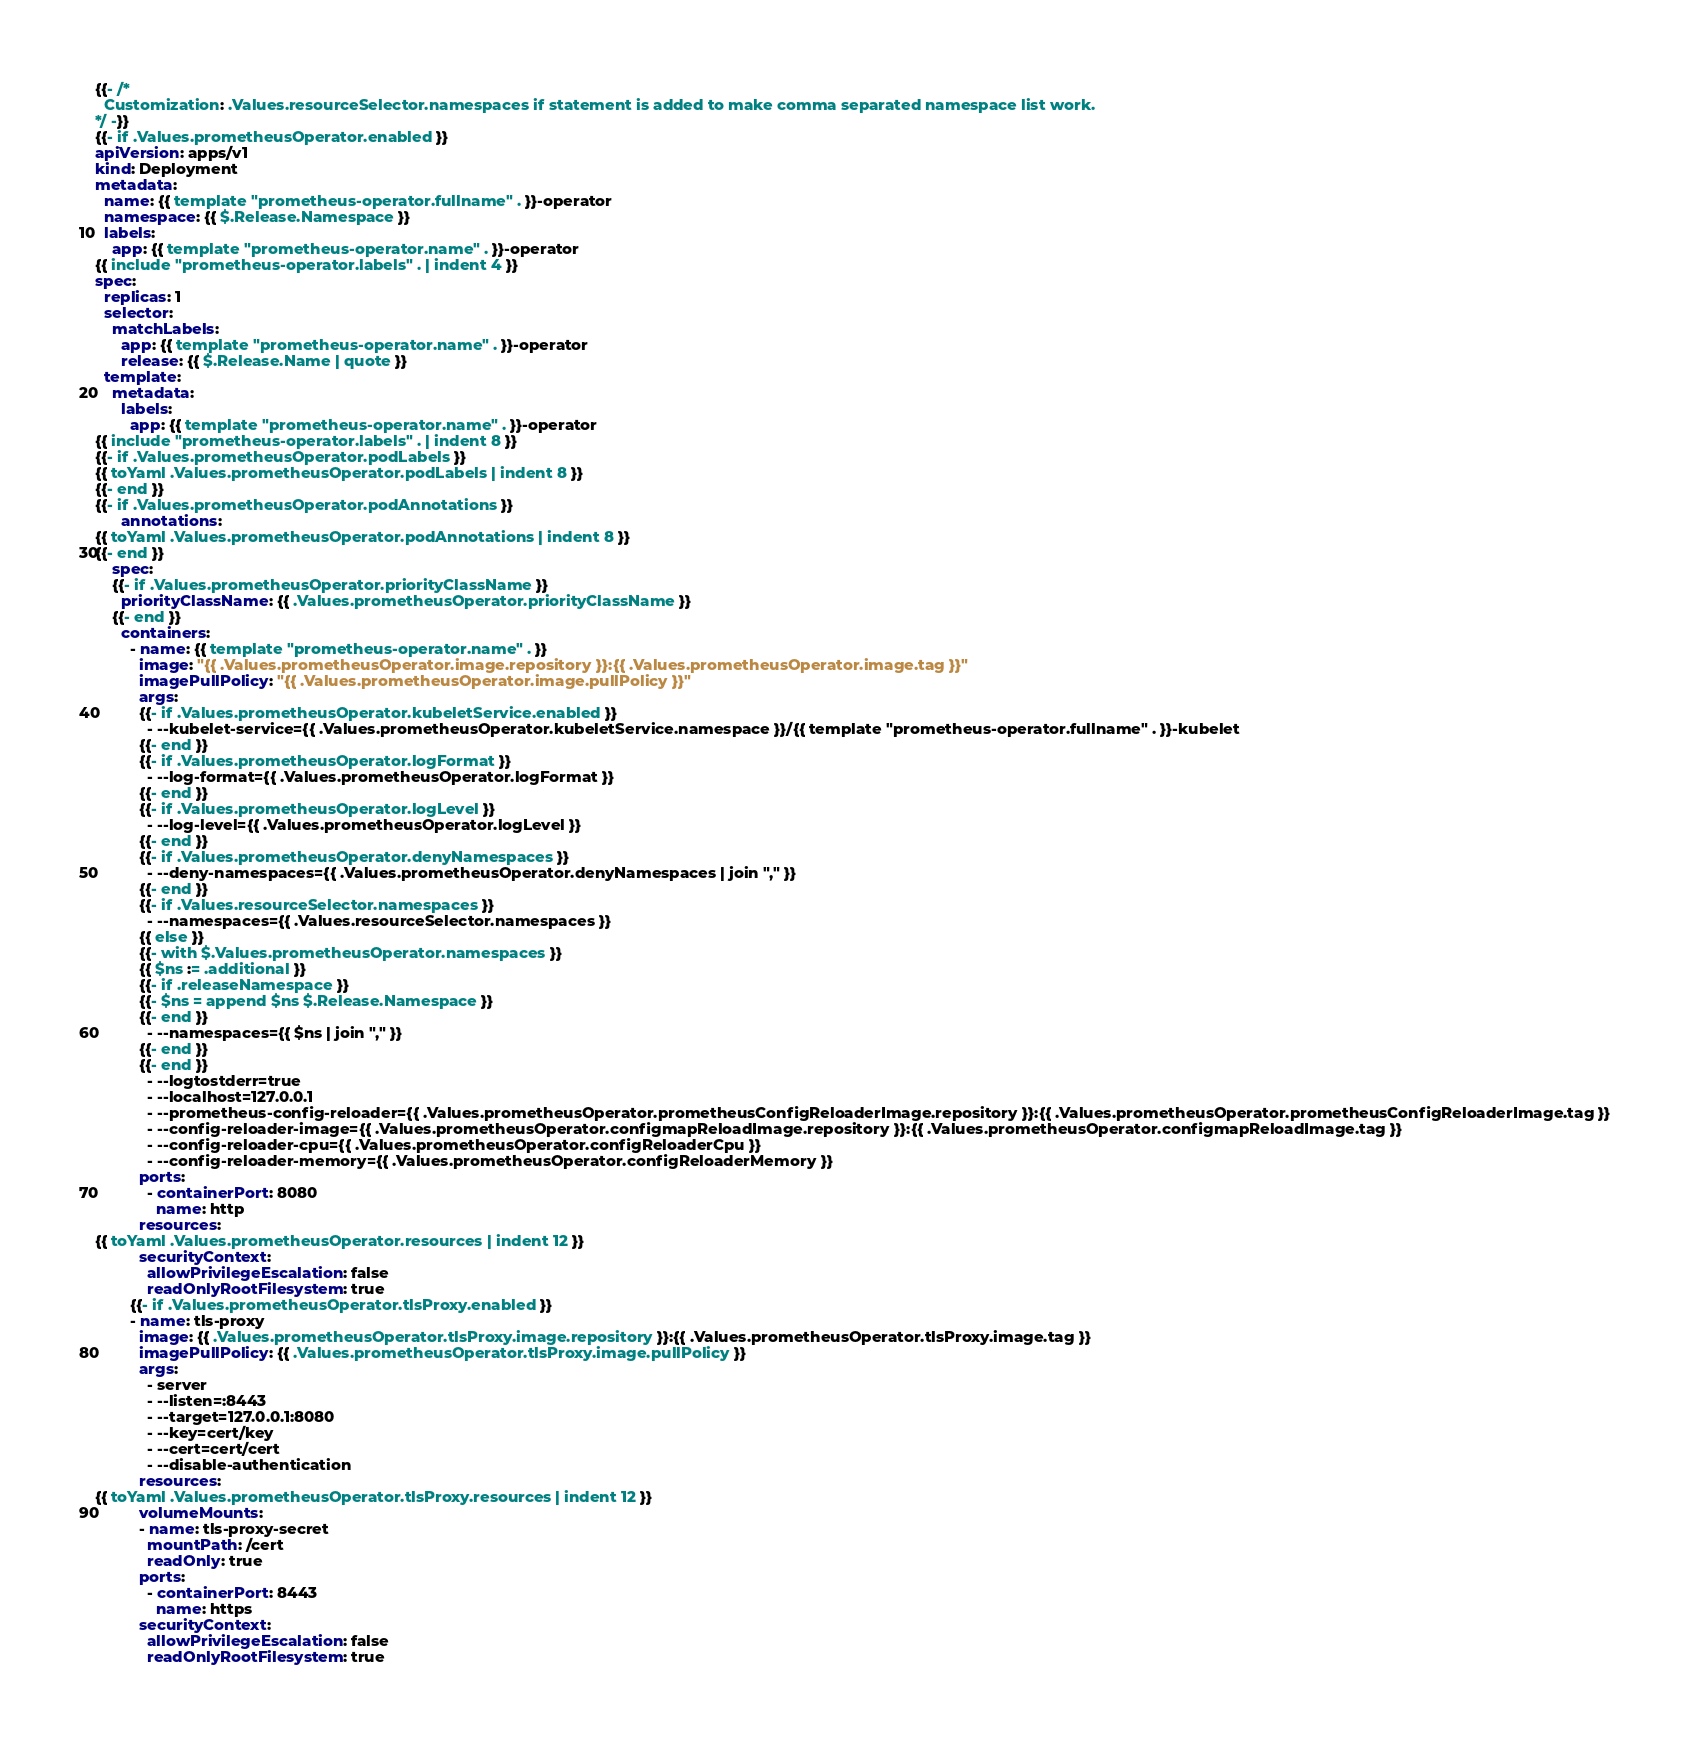<code> <loc_0><loc_0><loc_500><loc_500><_YAML_>{{- /*
  Customization: .Values.resourceSelector.namespaces if statement is added to make comma separated namespace list work.
*/ -}}
{{- if .Values.prometheusOperator.enabled }}
apiVersion: apps/v1
kind: Deployment
metadata:
  name: {{ template "prometheus-operator.fullname" . }}-operator
  namespace: {{ $.Release.Namespace }}
  labels:
    app: {{ template "prometheus-operator.name" . }}-operator
{{ include "prometheus-operator.labels" . | indent 4 }}
spec:
  replicas: 1
  selector:
    matchLabels:
      app: {{ template "prometheus-operator.name" . }}-operator
      release: {{ $.Release.Name | quote }}
  template:
    metadata:
      labels:
        app: {{ template "prometheus-operator.name" . }}-operator
{{ include "prometheus-operator.labels" . | indent 8 }}
{{- if .Values.prometheusOperator.podLabels }}
{{ toYaml .Values.prometheusOperator.podLabels | indent 8 }}
{{- end }}
{{- if .Values.prometheusOperator.podAnnotations }}
      annotations:
{{ toYaml .Values.prometheusOperator.podAnnotations | indent 8 }}
{{- end }}
    spec:
    {{- if .Values.prometheusOperator.priorityClassName }}
      priorityClassName: {{ .Values.prometheusOperator.priorityClassName }}
    {{- end }}
      containers:
        - name: {{ template "prometheus-operator.name" . }}
          image: "{{ .Values.prometheusOperator.image.repository }}:{{ .Values.prometheusOperator.image.tag }}"
          imagePullPolicy: "{{ .Values.prometheusOperator.image.pullPolicy }}"
          args:
          {{- if .Values.prometheusOperator.kubeletService.enabled }}
            - --kubelet-service={{ .Values.prometheusOperator.kubeletService.namespace }}/{{ template "prometheus-operator.fullname" . }}-kubelet
          {{- end }}
          {{- if .Values.prometheusOperator.logFormat }}
            - --log-format={{ .Values.prometheusOperator.logFormat }}
          {{- end }}
          {{- if .Values.prometheusOperator.logLevel }}
            - --log-level={{ .Values.prometheusOperator.logLevel }}
          {{- end }}
          {{- if .Values.prometheusOperator.denyNamespaces }}
            - --deny-namespaces={{ .Values.prometheusOperator.denyNamespaces | join "," }}
          {{- end }}
          {{- if .Values.resourceSelector.namespaces }}
            - --namespaces={{ .Values.resourceSelector.namespaces }}
          {{ else }}
          {{- with $.Values.prometheusOperator.namespaces }}
          {{ $ns := .additional }}
          {{- if .releaseNamespace }}
          {{- $ns = append $ns $.Release.Namespace }}
          {{- end }}
            - --namespaces={{ $ns | join "," }}
          {{- end }}
          {{- end }}
            - --logtostderr=true
            - --localhost=127.0.0.1
            - --prometheus-config-reloader={{ .Values.prometheusOperator.prometheusConfigReloaderImage.repository }}:{{ .Values.prometheusOperator.prometheusConfigReloaderImage.tag }}
            - --config-reloader-image={{ .Values.prometheusOperator.configmapReloadImage.repository }}:{{ .Values.prometheusOperator.configmapReloadImage.tag }}
            - --config-reloader-cpu={{ .Values.prometheusOperator.configReloaderCpu }}
            - --config-reloader-memory={{ .Values.prometheusOperator.configReloaderMemory }}
          ports:
            - containerPort: 8080
              name: http
          resources:
{{ toYaml .Values.prometheusOperator.resources | indent 12 }}
          securityContext:
            allowPrivilegeEscalation: false
            readOnlyRootFilesystem: true
        {{- if .Values.prometheusOperator.tlsProxy.enabled }}
        - name: tls-proxy
          image: {{ .Values.prometheusOperator.tlsProxy.image.repository }}:{{ .Values.prometheusOperator.tlsProxy.image.tag }}
          imagePullPolicy: {{ .Values.prometheusOperator.tlsProxy.image.pullPolicy }}
          args:
            - server
            - --listen=:8443
            - --target=127.0.0.1:8080
            - --key=cert/key
            - --cert=cert/cert
            - --disable-authentication
          resources:
{{ toYaml .Values.prometheusOperator.tlsProxy.resources | indent 12 }}
          volumeMounts:
          - name: tls-proxy-secret
            mountPath: /cert
            readOnly: true
          ports:
            - containerPort: 8443
              name: https
          securityContext:
            allowPrivilegeEscalation: false
            readOnlyRootFilesystem: true</code> 